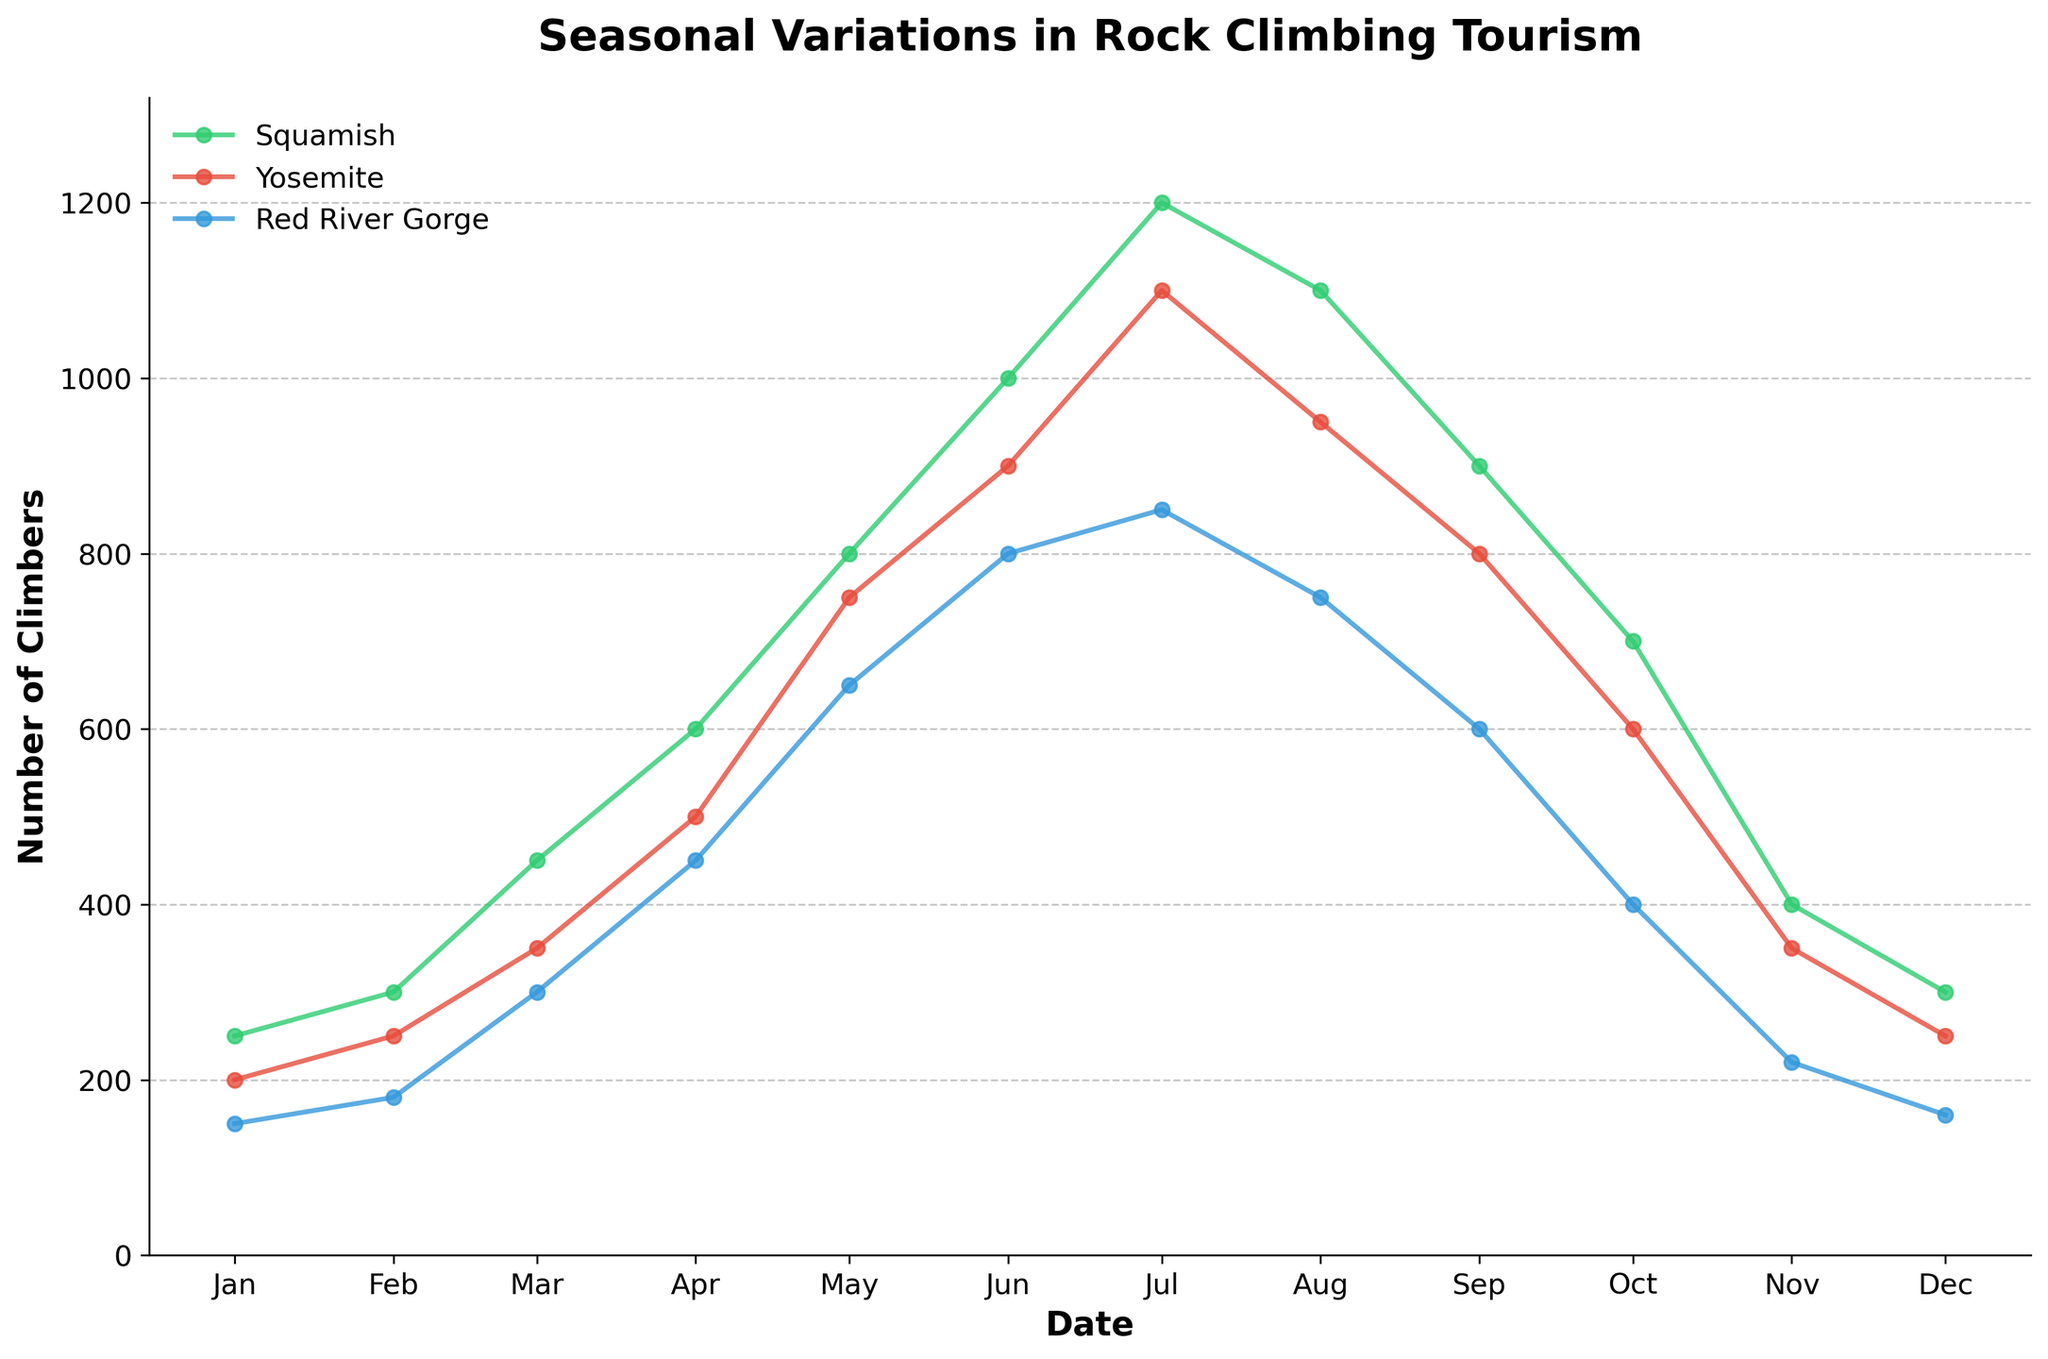Which location has the highest number of climbers in July? Looking at the line plot for the month of July, identify the peak of each location's line and compare their values.
Answer: Squamish What is the general trend in the number of climbers from January to December in Yosemite? Track the line representing Yosemite from January to December, noting how values rise and fall over time.
Answer: The trend starts low, peaks in July, and decreases again towards December During which month does Red River Gorge see the highest number of climbers? Observe the Red River Gorge line and find the highest point along the time axis to identify the month.
Answer: July How does the number of climbers in June at Red River Gorge compare to that of Yosemite in the same month? Locate the points for June on the Red River Gorge and Yosemite lines and compare their y-values.
Answer: Lower Which month exhibits the steepest increase in the number of climbers for Squamish? Examine the line for Squamish and identify where the sharpest upward slope occurs between two consecutive months.
Answer: April to May Calculate the average number of climbers for Squamish over the year. Sum the number of climbers for each month in Squamish and divide by 12 (the number of months). The values are: 250+300+450+600+800+1000+1200+1100+900+700+400+300 = 8000. Divide this by 12.
Answer: 666.67 Compare the overall range in the number of climbers between Yosemite and Squamish. For each location, subtract the smallest value from the largest value. For Yosemite: 1100 - 200 = 900; for Squamish: 1200 - 250 = 950.
Answer: Squamish has a wider range Does Red River Gorge have any months where the number of climbers decreases subsequently? Follow the Red River Gorge line and observe any descending patterns month over month.
Answer: Yes, from July to December In which season does Yosemite attract the most climbers and what might this indicate? The peak in Yosemite occurs during the summer months, particularly July and August.
Answer: Summer; it indicates Yosemite's popularity in summer How does the number of climbers change from April to May for each location? Observe the increase in the number of climbers from April to May for Squamish, Yosemite, and Red River Gorge by noting the difference in y-values between these two months.
Answer: Squamish: +200, Yosemite: +250, Red River Gorge: +200 